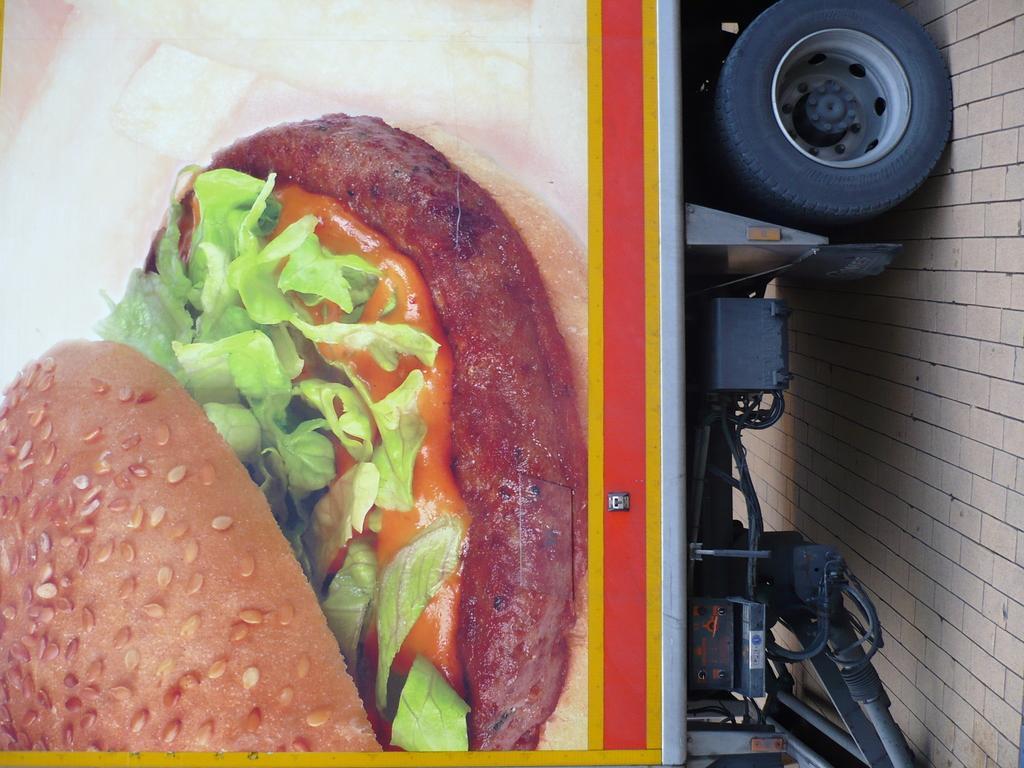How would you summarize this image in a sentence or two? In this image there is a vehicle, there is food on the vehicle, where is the ground towards the right of the image. 